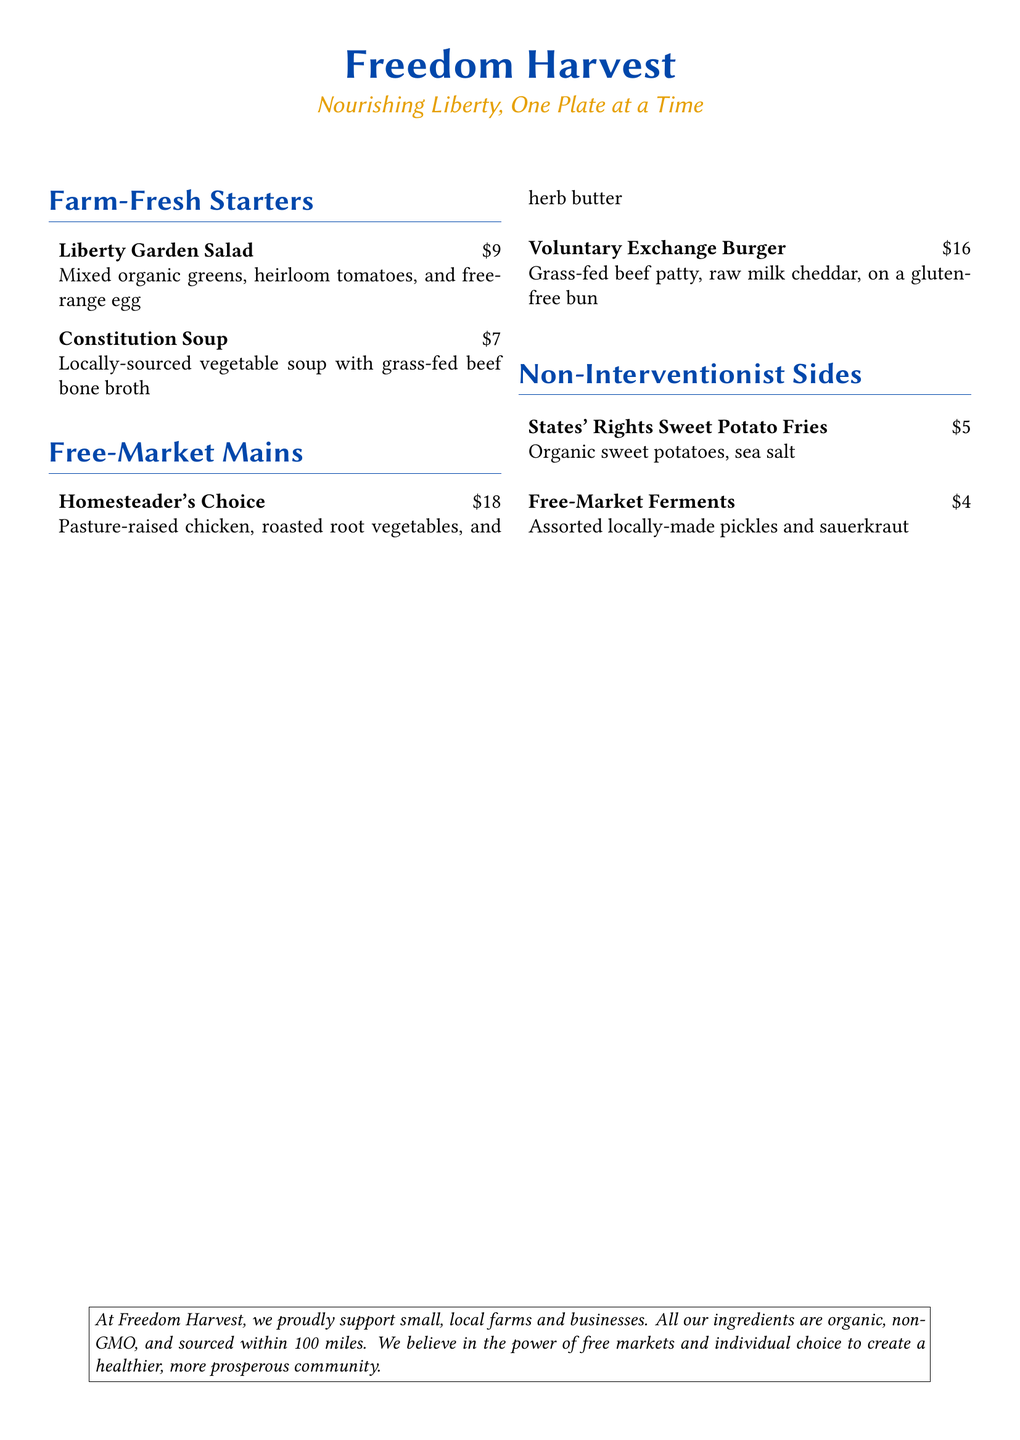what is the price of the Liberty Garden Salad? The price is stated next to the item on the menu.
Answer: $9 what type of ingredients does Freedom Harvest emphasize? This information is provided in the note at the bottom of the menu.
Answer: Organic, non-GMO how much does the Homesteader's Choice cost? The cost is indicated next to the dish in the menu.
Answer: $18 what is the main ingredient in the Constitution Soup? The primary ingredient is mentioned in the description of the dish.
Answer: Grass-fed beef bone broth which item is offered as a side? This item is found in the "Non-Interventionist Sides" section of the menu.
Answer: States' Rights Sweet Potato Fries how far does Freedom Harvest source its ingredients? The distance is mentioned in the note at the bottom of the menu.
Answer: 100 miles what type of meat is used in the Voluntary Exchange Burger? The type of meat is indicated in the description of the burger.
Answer: Grass-fed beef who does Freedom Harvest support according to the menu? This information is stated in the note at the bottom.
Answer: Small, local farms and businesses what are the two main sections of the menu? These sections are indicated by the titles in the menu structure.
Answer: Farm-Fresh Starters, Free-Market Mains 